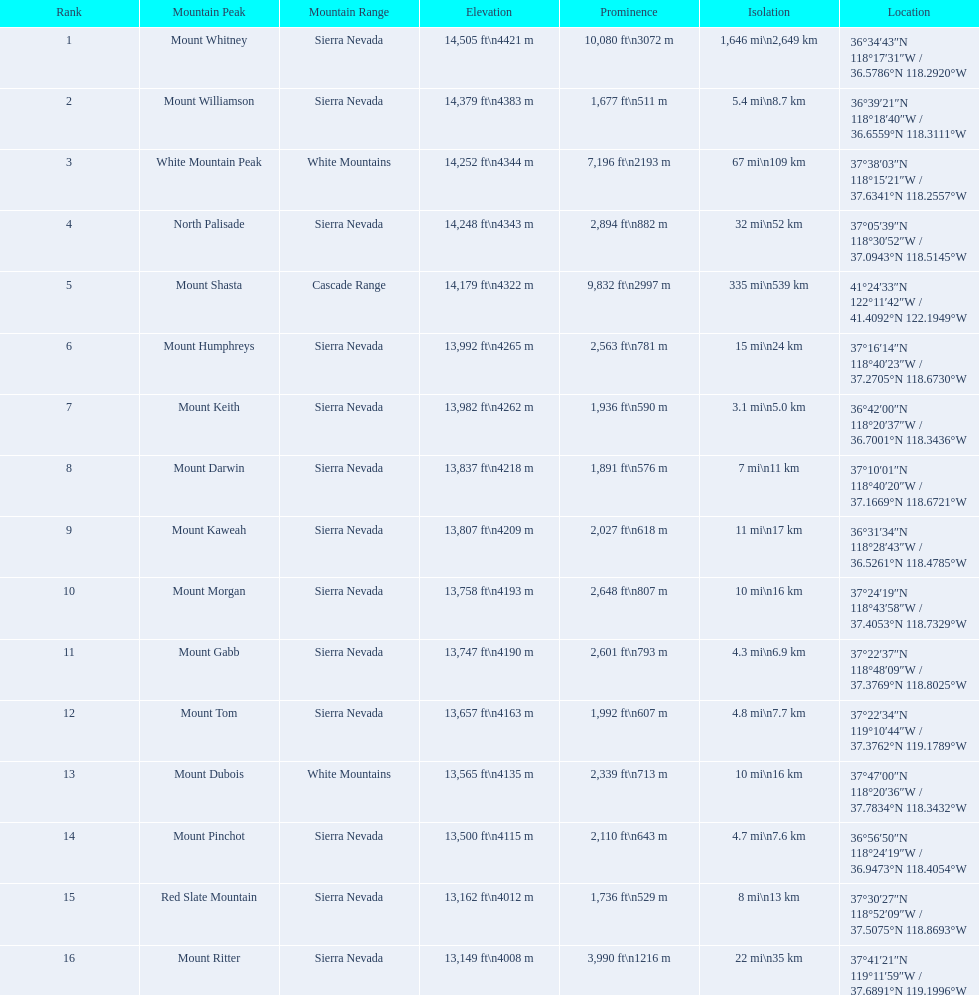Which mountain peaks are lower than 14,000 ft? Mount Humphreys, Mount Keith, Mount Darwin, Mount Kaweah, Mount Morgan, Mount Gabb, Mount Tom, Mount Dubois, Mount Pinchot, Red Slate Mountain, Mount Ritter. Are any of them below 13,500? if so, which ones? Red Slate Mountain, Mount Ritter. What's the lowest peak? 13,149 ft\n4008 m. Which one is that? Mount Ritter. 